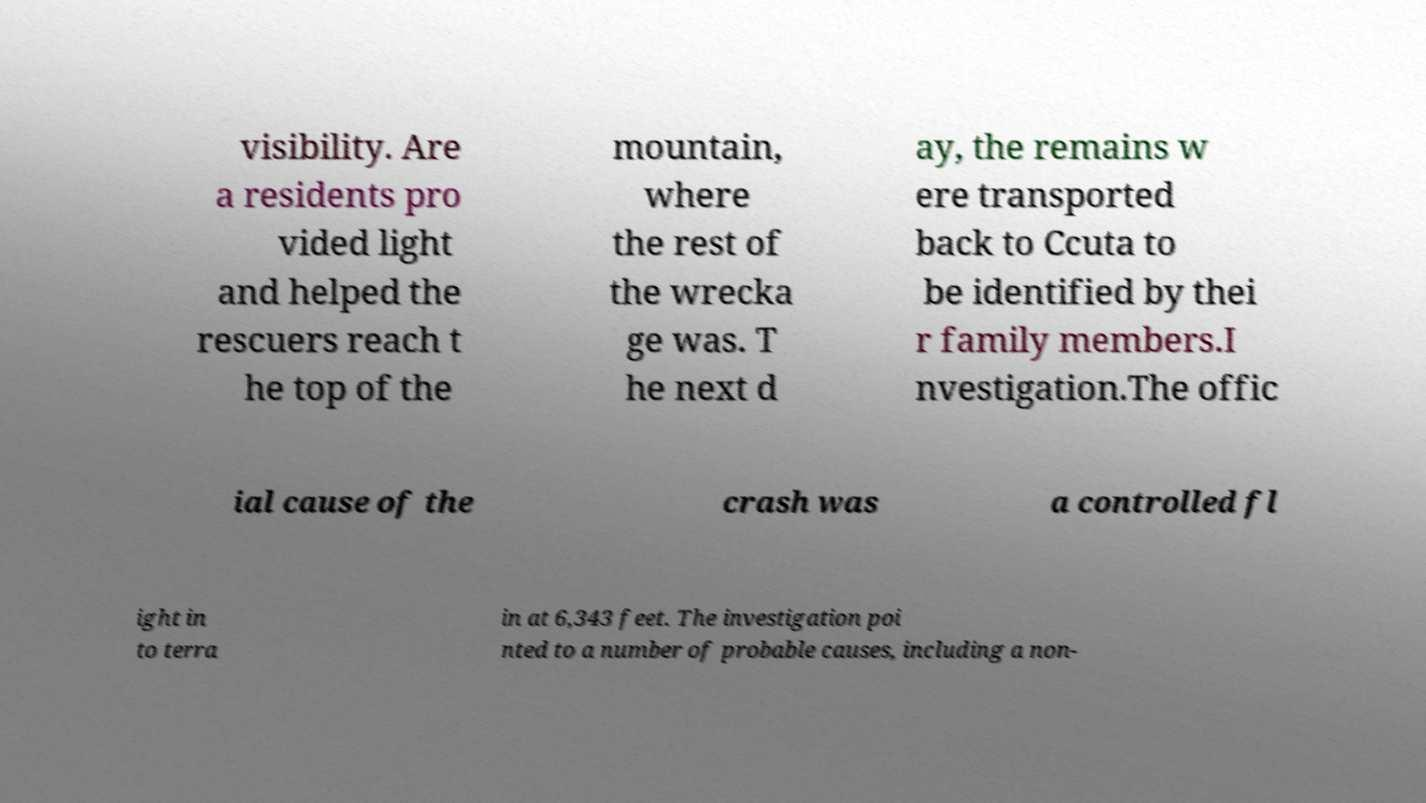What messages or text are displayed in this image? I need them in a readable, typed format. visibility. Are a residents pro vided light and helped the rescuers reach t he top of the mountain, where the rest of the wrecka ge was. T he next d ay, the remains w ere transported back to Ccuta to be identified by thei r family members.I nvestigation.The offic ial cause of the crash was a controlled fl ight in to terra in at 6,343 feet. The investigation poi nted to a number of probable causes, including a non- 